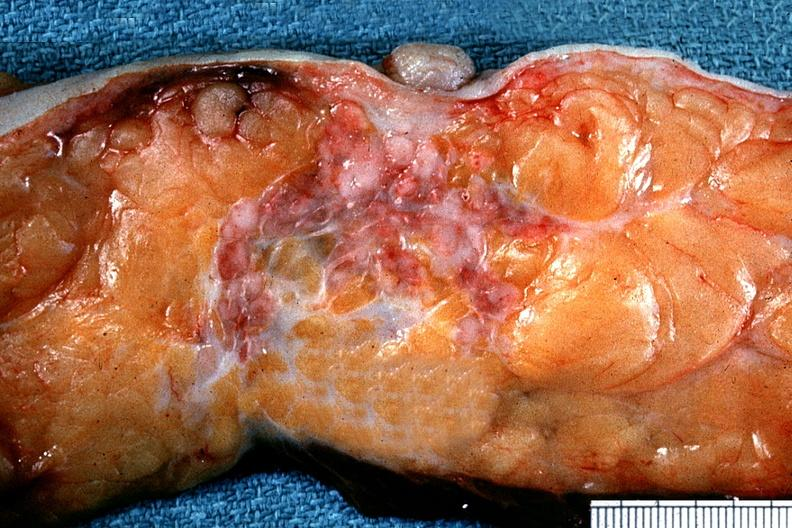s adenocarcinoma present?
Answer the question using a single word or phrase. Yes 